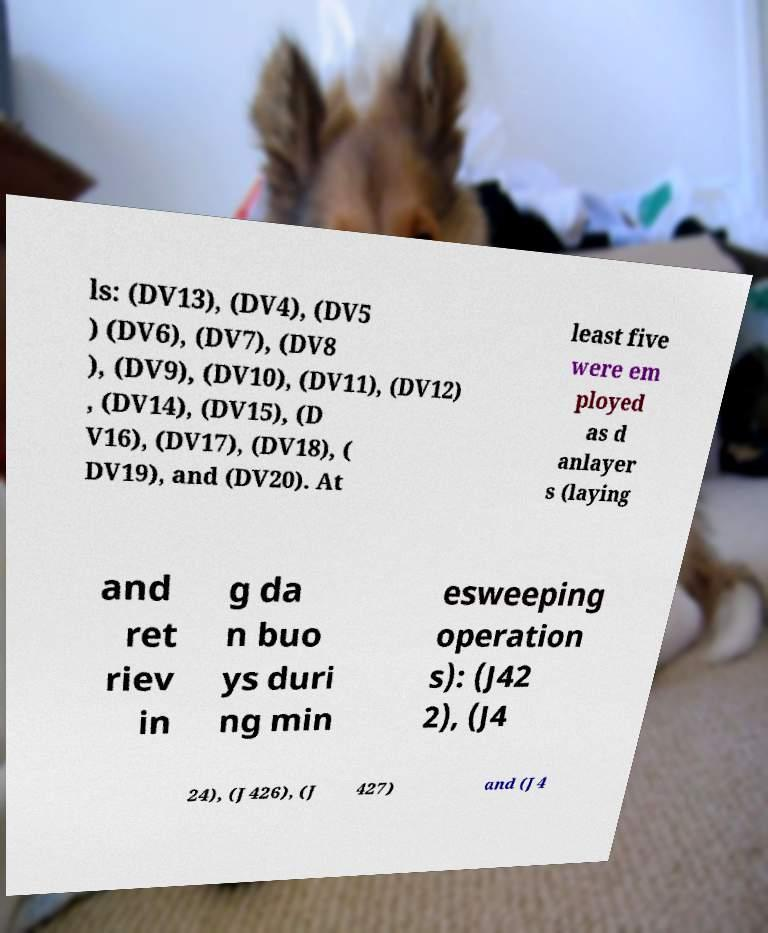Could you extract and type out the text from this image? ls: (DV13), (DV4), (DV5 ) (DV6), (DV7), (DV8 ), (DV9), (DV10), (DV11), (DV12) , (DV14), (DV15), (D V16), (DV17), (DV18), ( DV19), and (DV20). At least five were em ployed as d anlayer s (laying and ret riev in g da n buo ys duri ng min esweeping operation s): (J42 2), (J4 24), (J426), (J 427) and (J4 